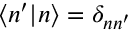Convert formula to latex. <formula><loc_0><loc_0><loc_500><loc_500>\langle n ^ { \prime } | n \rangle = \delta _ { n n ^ { \prime } }</formula> 